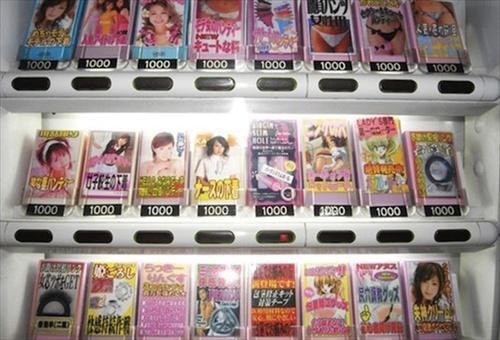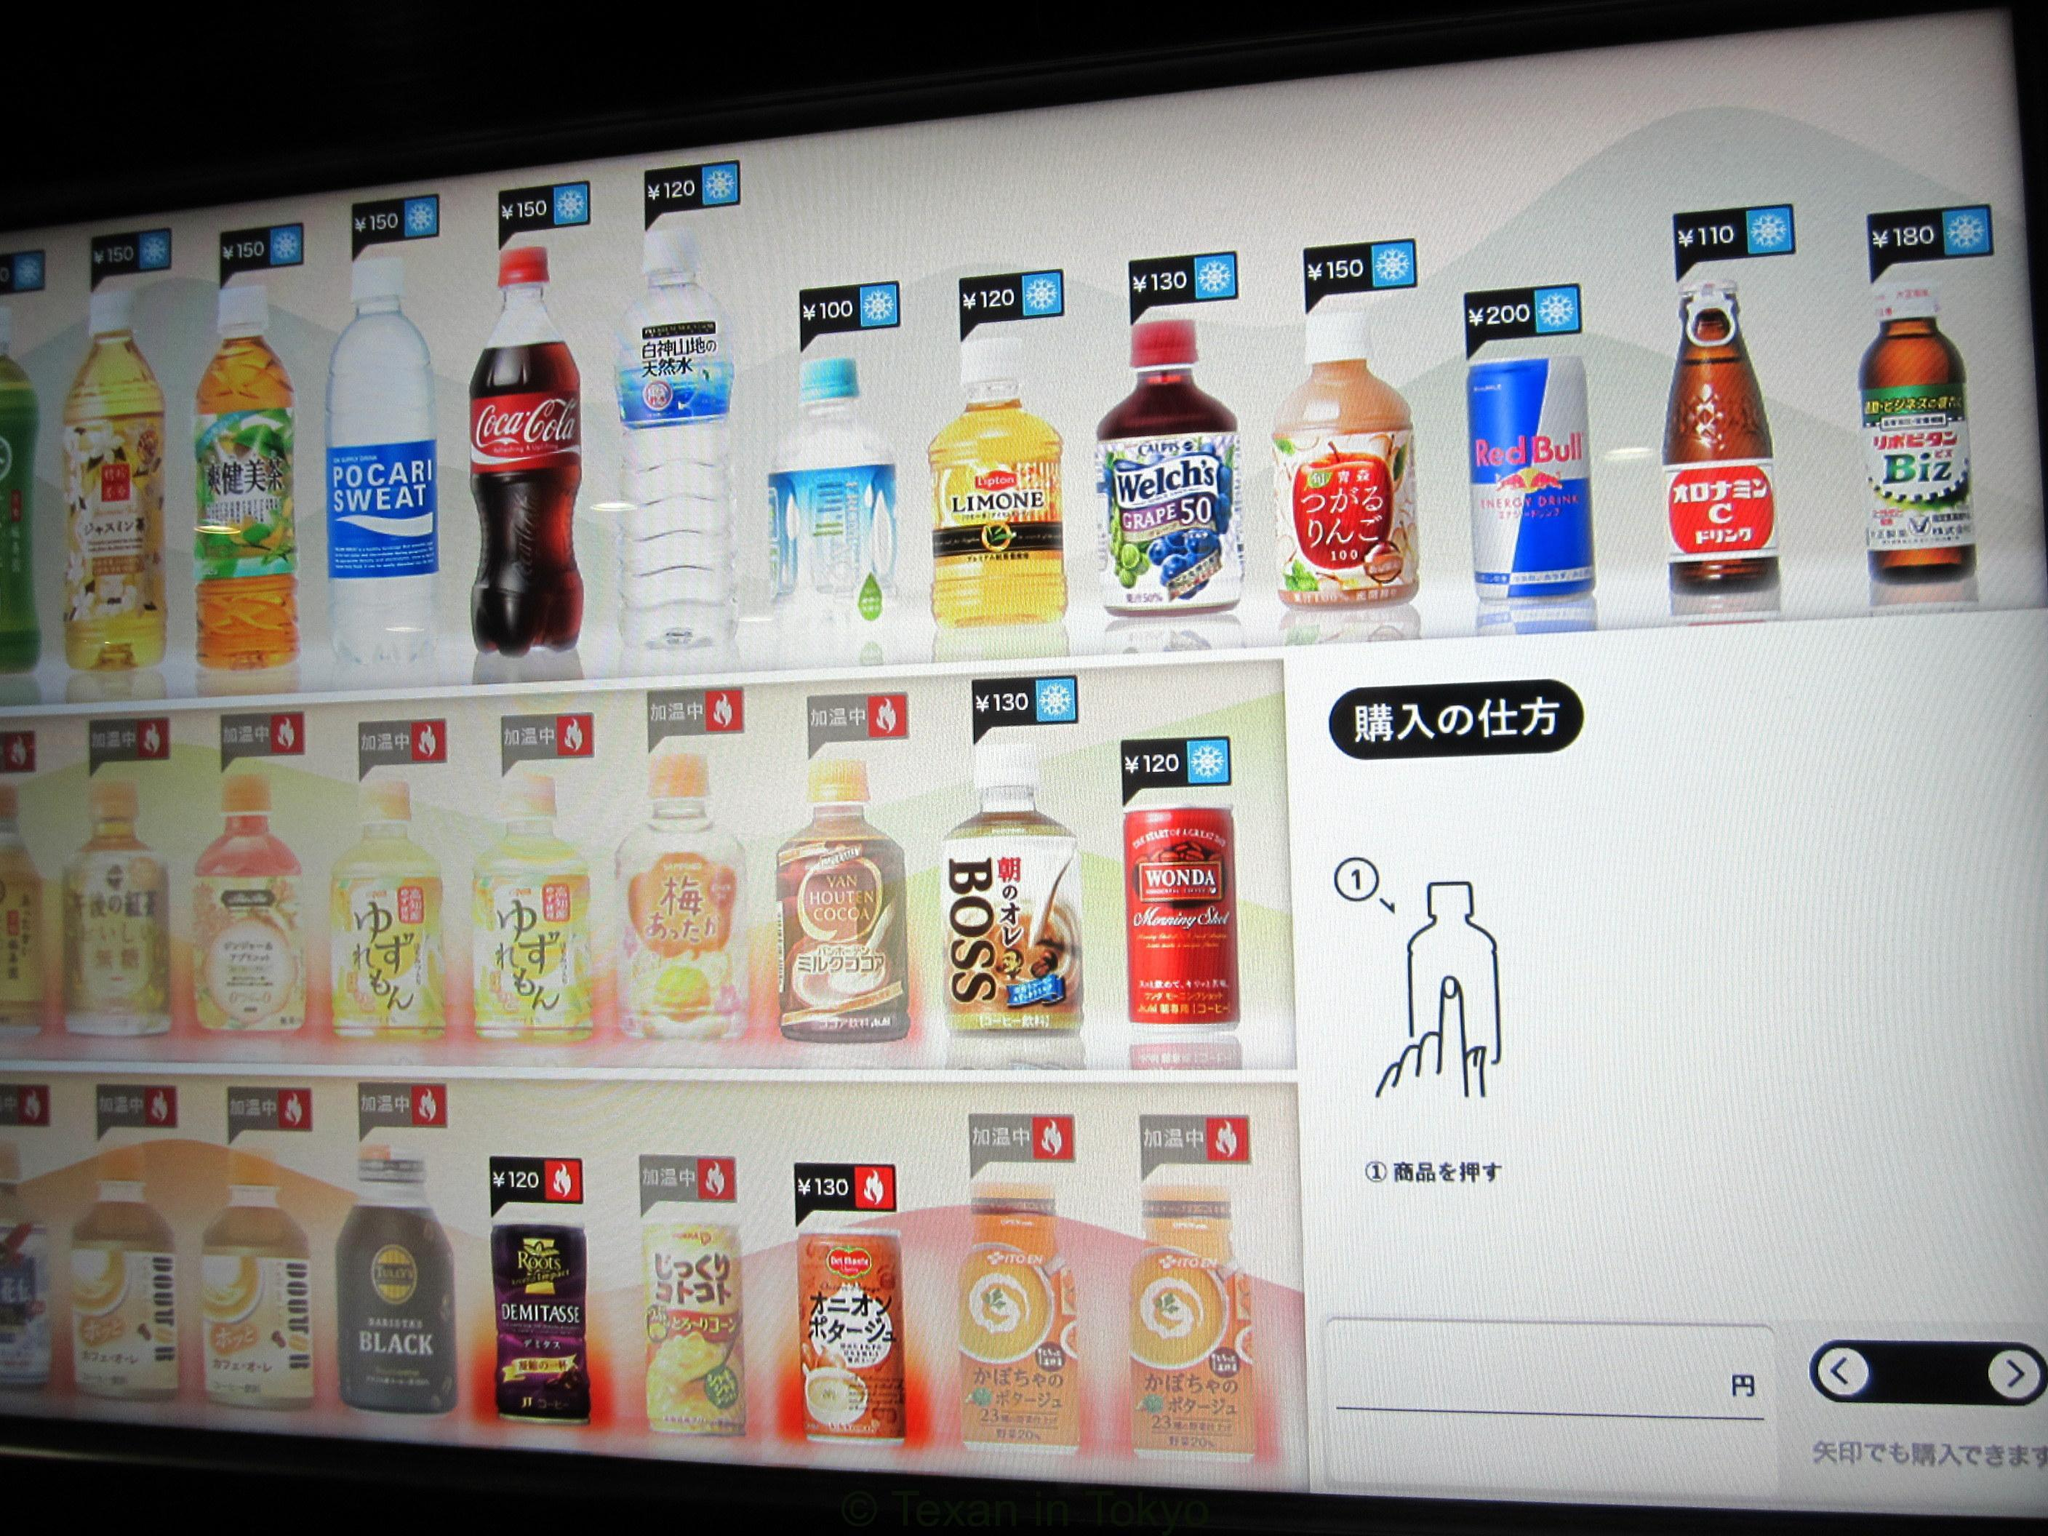The first image is the image on the left, the second image is the image on the right. For the images shown, is this caption "At least one vending machine has a background with bright blue predominant." true? Answer yes or no. No. The first image is the image on the left, the second image is the image on the right. Given the left and right images, does the statement "The wall against which the vending machine is placed can be seen in one of the images." hold true? Answer yes or no. No. 